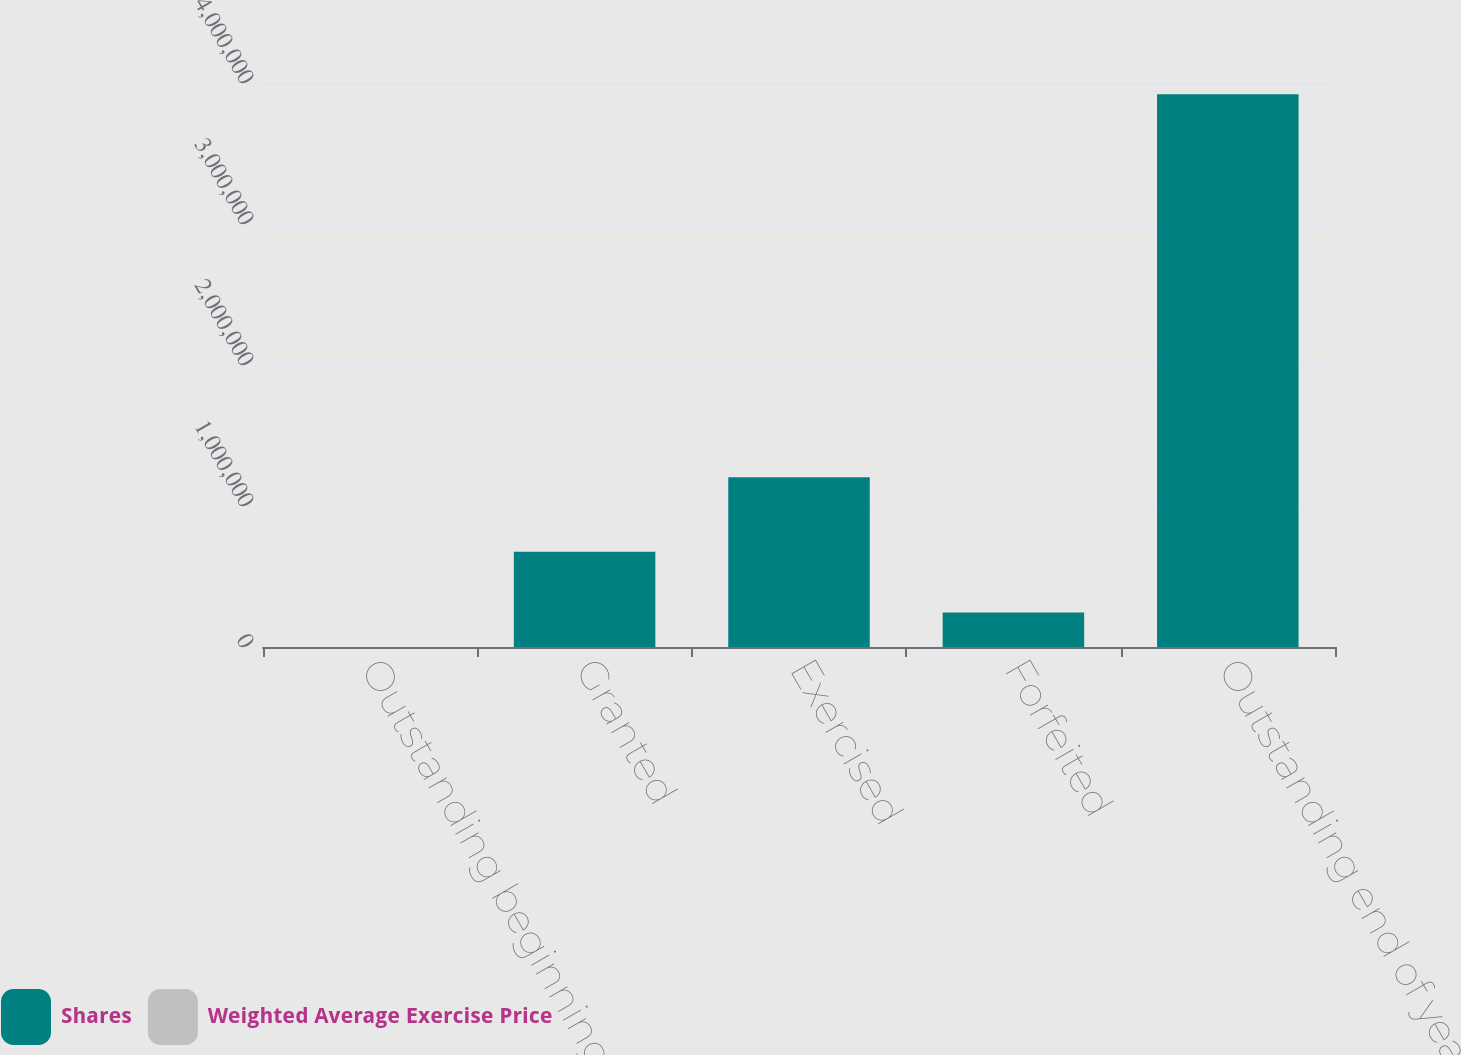<chart> <loc_0><loc_0><loc_500><loc_500><stacked_bar_chart><ecel><fcel>Outstanding beginning of year<fcel>Granted<fcel>Exercised<fcel>Forfeited<fcel>Outstanding end of year<nl><fcel>Shares<fcel>23.37<fcel>676038<fcel>1.20353e+06<fcel>243965<fcel>3.9202e+06<nl><fcel>Weighted Average Exercise Price<fcel>21.12<fcel>23.37<fcel>18.82<fcel>22.96<fcel>22.09<nl></chart> 